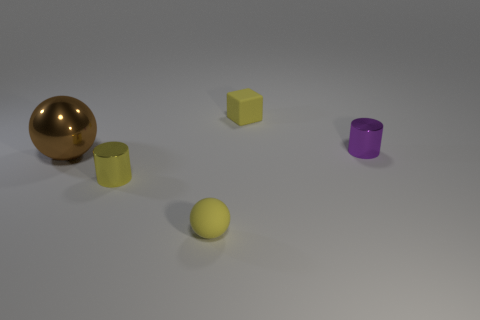What number of yellow objects are either small cylinders or small matte things?
Provide a succinct answer. 3. Are there any small balls right of the tiny yellow rubber object that is behind the shiny sphere that is left of the small purple cylinder?
Offer a terse response. No. Are there fewer yellow matte things than rubber blocks?
Give a very brief answer. No. There is a yellow matte object to the left of the tiny block; is it the same shape as the large brown metallic thing?
Ensure brevity in your answer.  Yes. Are any brown shiny balls visible?
Your answer should be very brief. Yes. What is the color of the large thing that is on the left side of the small metal cylinder that is behind the small metal object on the left side of the yellow block?
Your answer should be very brief. Brown. Are there the same number of small purple cylinders in front of the big metallic sphere and big spheres that are behind the tiny matte ball?
Give a very brief answer. No. What is the shape of the yellow shiny object that is the same size as the purple cylinder?
Ensure brevity in your answer.  Cylinder. Is there a cylinder of the same color as the matte sphere?
Keep it short and to the point. Yes. What is the shape of the yellow object to the left of the tiny sphere?
Your answer should be compact. Cylinder. 